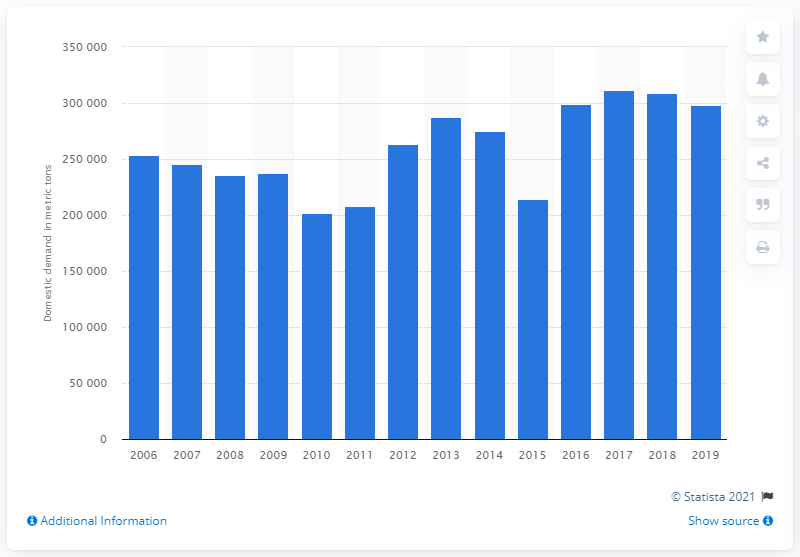Draw attention to some important aspects in this diagram. In 2019, the domestic demand for poly propylene glycol in South Korea was approximately 298,273 units. 